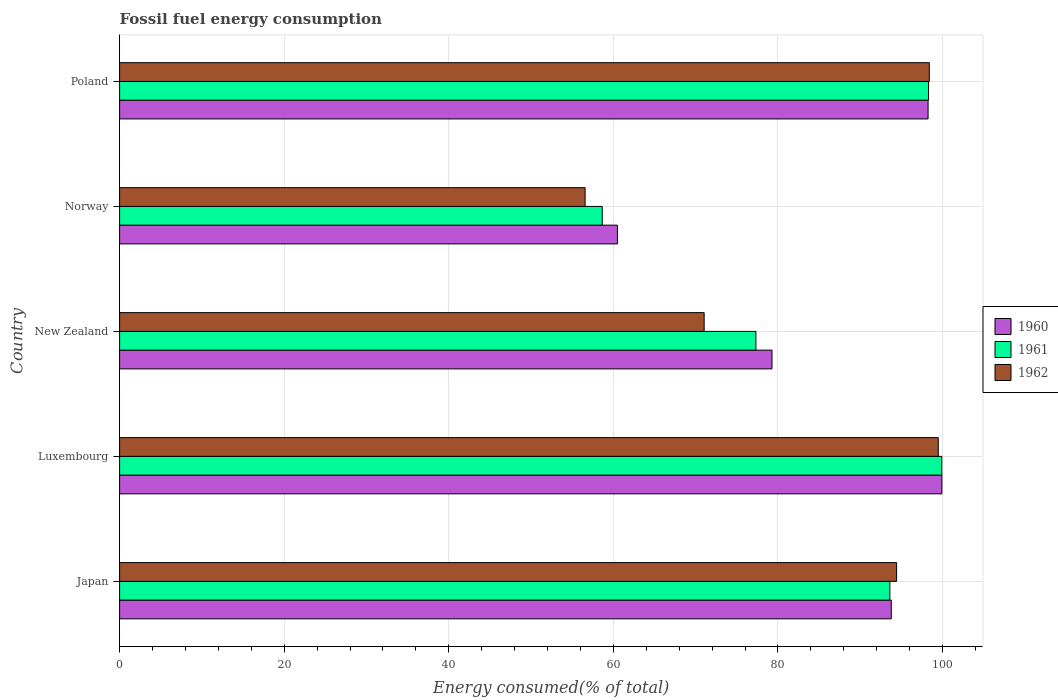Are the number of bars per tick equal to the number of legend labels?
Your answer should be compact. Yes. Are the number of bars on each tick of the Y-axis equal?
Provide a succinct answer. Yes. How many bars are there on the 4th tick from the top?
Your answer should be very brief. 3. How many bars are there on the 4th tick from the bottom?
Keep it short and to the point. 3. What is the label of the 4th group of bars from the top?
Your answer should be very brief. Luxembourg. What is the percentage of energy consumed in 1962 in Poland?
Your answer should be compact. 98.4. Across all countries, what is the maximum percentage of energy consumed in 1961?
Make the answer very short. 99.91. Across all countries, what is the minimum percentage of energy consumed in 1962?
Offer a very short reply. 56.57. In which country was the percentage of energy consumed in 1960 maximum?
Ensure brevity in your answer.  Luxembourg. What is the total percentage of energy consumed in 1962 in the graph?
Your answer should be very brief. 419.91. What is the difference between the percentage of energy consumed in 1961 in Japan and that in New Zealand?
Your response must be concise. 16.28. What is the difference between the percentage of energy consumed in 1960 in New Zealand and the percentage of energy consumed in 1962 in Norway?
Your answer should be very brief. 22.71. What is the average percentage of energy consumed in 1960 per country?
Give a very brief answer. 86.34. What is the difference between the percentage of energy consumed in 1960 and percentage of energy consumed in 1962 in New Zealand?
Your response must be concise. 8.24. What is the ratio of the percentage of energy consumed in 1960 in Luxembourg to that in Poland?
Keep it short and to the point. 1.02. Is the percentage of energy consumed in 1962 in Japan less than that in Norway?
Your answer should be very brief. No. Is the difference between the percentage of energy consumed in 1960 in Luxembourg and Poland greater than the difference between the percentage of energy consumed in 1962 in Luxembourg and Poland?
Offer a very short reply. Yes. What is the difference between the highest and the second highest percentage of energy consumed in 1960?
Offer a very short reply. 1.68. What is the difference between the highest and the lowest percentage of energy consumed in 1960?
Provide a succinct answer. 39.43. In how many countries, is the percentage of energy consumed in 1962 greater than the average percentage of energy consumed in 1962 taken over all countries?
Ensure brevity in your answer.  3. What does the 3rd bar from the top in Luxembourg represents?
Offer a terse response. 1960. Are all the bars in the graph horizontal?
Your answer should be compact. Yes. How many countries are there in the graph?
Offer a terse response. 5. What is the difference between two consecutive major ticks on the X-axis?
Keep it short and to the point. 20. Does the graph contain grids?
Offer a very short reply. Yes. How are the legend labels stacked?
Keep it short and to the point. Vertical. What is the title of the graph?
Your response must be concise. Fossil fuel energy consumption. What is the label or title of the X-axis?
Your answer should be very brief. Energy consumed(% of total). What is the Energy consumed(% of total) of 1960 in Japan?
Provide a short and direct response. 93.78. What is the Energy consumed(% of total) in 1961 in Japan?
Ensure brevity in your answer.  93.6. What is the Energy consumed(% of total) in 1962 in Japan?
Your answer should be compact. 94.42. What is the Energy consumed(% of total) in 1960 in Luxembourg?
Give a very brief answer. 99.92. What is the Energy consumed(% of total) in 1961 in Luxembourg?
Ensure brevity in your answer.  99.91. What is the Energy consumed(% of total) of 1962 in Luxembourg?
Offer a very short reply. 99.49. What is the Energy consumed(% of total) of 1960 in New Zealand?
Keep it short and to the point. 79.28. What is the Energy consumed(% of total) in 1961 in New Zealand?
Your response must be concise. 77.33. What is the Energy consumed(% of total) in 1962 in New Zealand?
Offer a terse response. 71.04. What is the Energy consumed(% of total) of 1960 in Norway?
Keep it short and to the point. 60.5. What is the Energy consumed(% of total) in 1961 in Norway?
Give a very brief answer. 58.65. What is the Energy consumed(% of total) of 1962 in Norway?
Provide a short and direct response. 56.57. What is the Energy consumed(% of total) in 1960 in Poland?
Keep it short and to the point. 98.25. What is the Energy consumed(% of total) of 1961 in Poland?
Ensure brevity in your answer.  98.3. What is the Energy consumed(% of total) in 1962 in Poland?
Ensure brevity in your answer.  98.4. Across all countries, what is the maximum Energy consumed(% of total) of 1960?
Provide a short and direct response. 99.92. Across all countries, what is the maximum Energy consumed(% of total) in 1961?
Offer a very short reply. 99.91. Across all countries, what is the maximum Energy consumed(% of total) in 1962?
Provide a short and direct response. 99.49. Across all countries, what is the minimum Energy consumed(% of total) of 1960?
Your answer should be compact. 60.5. Across all countries, what is the minimum Energy consumed(% of total) in 1961?
Provide a succinct answer. 58.65. Across all countries, what is the minimum Energy consumed(% of total) in 1962?
Your answer should be compact. 56.57. What is the total Energy consumed(% of total) in 1960 in the graph?
Provide a succinct answer. 431.72. What is the total Energy consumed(% of total) of 1961 in the graph?
Your answer should be very brief. 427.8. What is the total Energy consumed(% of total) in 1962 in the graph?
Ensure brevity in your answer.  419.91. What is the difference between the Energy consumed(% of total) in 1960 in Japan and that in Luxembourg?
Your answer should be very brief. -6.15. What is the difference between the Energy consumed(% of total) in 1961 in Japan and that in Luxembourg?
Offer a terse response. -6.31. What is the difference between the Energy consumed(% of total) in 1962 in Japan and that in Luxembourg?
Give a very brief answer. -5.07. What is the difference between the Energy consumed(% of total) of 1960 in Japan and that in New Zealand?
Your answer should be compact. 14.5. What is the difference between the Energy consumed(% of total) of 1961 in Japan and that in New Zealand?
Your answer should be compact. 16.28. What is the difference between the Energy consumed(% of total) in 1962 in Japan and that in New Zealand?
Make the answer very short. 23.38. What is the difference between the Energy consumed(% of total) of 1960 in Japan and that in Norway?
Ensure brevity in your answer.  33.28. What is the difference between the Energy consumed(% of total) in 1961 in Japan and that in Norway?
Give a very brief answer. 34.95. What is the difference between the Energy consumed(% of total) in 1962 in Japan and that in Norway?
Make the answer very short. 37.85. What is the difference between the Energy consumed(% of total) of 1960 in Japan and that in Poland?
Keep it short and to the point. -4.47. What is the difference between the Energy consumed(% of total) in 1961 in Japan and that in Poland?
Keep it short and to the point. -4.7. What is the difference between the Energy consumed(% of total) in 1962 in Japan and that in Poland?
Make the answer very short. -3.98. What is the difference between the Energy consumed(% of total) in 1960 in Luxembourg and that in New Zealand?
Provide a succinct answer. 20.65. What is the difference between the Energy consumed(% of total) in 1961 in Luxembourg and that in New Zealand?
Ensure brevity in your answer.  22.58. What is the difference between the Energy consumed(% of total) in 1962 in Luxembourg and that in New Zealand?
Your answer should be compact. 28.45. What is the difference between the Energy consumed(% of total) of 1960 in Luxembourg and that in Norway?
Your response must be concise. 39.43. What is the difference between the Energy consumed(% of total) in 1961 in Luxembourg and that in Norway?
Offer a terse response. 41.26. What is the difference between the Energy consumed(% of total) of 1962 in Luxembourg and that in Norway?
Make the answer very short. 42.92. What is the difference between the Energy consumed(% of total) in 1960 in Luxembourg and that in Poland?
Offer a very short reply. 1.68. What is the difference between the Energy consumed(% of total) in 1961 in Luxembourg and that in Poland?
Provide a short and direct response. 1.61. What is the difference between the Energy consumed(% of total) of 1962 in Luxembourg and that in Poland?
Offer a very short reply. 1.09. What is the difference between the Energy consumed(% of total) of 1960 in New Zealand and that in Norway?
Offer a terse response. 18.78. What is the difference between the Energy consumed(% of total) in 1961 in New Zealand and that in Norway?
Offer a terse response. 18.68. What is the difference between the Energy consumed(% of total) in 1962 in New Zealand and that in Norway?
Your answer should be compact. 14.47. What is the difference between the Energy consumed(% of total) in 1960 in New Zealand and that in Poland?
Keep it short and to the point. -18.97. What is the difference between the Energy consumed(% of total) of 1961 in New Zealand and that in Poland?
Your answer should be very brief. -20.98. What is the difference between the Energy consumed(% of total) of 1962 in New Zealand and that in Poland?
Your response must be concise. -27.36. What is the difference between the Energy consumed(% of total) in 1960 in Norway and that in Poland?
Offer a very short reply. -37.75. What is the difference between the Energy consumed(% of total) in 1961 in Norway and that in Poland?
Keep it short and to the point. -39.65. What is the difference between the Energy consumed(% of total) in 1962 in Norway and that in Poland?
Ensure brevity in your answer.  -41.83. What is the difference between the Energy consumed(% of total) in 1960 in Japan and the Energy consumed(% of total) in 1961 in Luxembourg?
Provide a succinct answer. -6.14. What is the difference between the Energy consumed(% of total) in 1960 in Japan and the Energy consumed(% of total) in 1962 in Luxembourg?
Offer a very short reply. -5.71. What is the difference between the Energy consumed(% of total) in 1961 in Japan and the Energy consumed(% of total) in 1962 in Luxembourg?
Your answer should be compact. -5.88. What is the difference between the Energy consumed(% of total) of 1960 in Japan and the Energy consumed(% of total) of 1961 in New Zealand?
Give a very brief answer. 16.45. What is the difference between the Energy consumed(% of total) of 1960 in Japan and the Energy consumed(% of total) of 1962 in New Zealand?
Keep it short and to the point. 22.74. What is the difference between the Energy consumed(% of total) in 1961 in Japan and the Energy consumed(% of total) in 1962 in New Zealand?
Your answer should be compact. 22.57. What is the difference between the Energy consumed(% of total) of 1960 in Japan and the Energy consumed(% of total) of 1961 in Norway?
Keep it short and to the point. 35.12. What is the difference between the Energy consumed(% of total) of 1960 in Japan and the Energy consumed(% of total) of 1962 in Norway?
Keep it short and to the point. 37.21. What is the difference between the Energy consumed(% of total) in 1961 in Japan and the Energy consumed(% of total) in 1962 in Norway?
Your answer should be compact. 37.03. What is the difference between the Energy consumed(% of total) of 1960 in Japan and the Energy consumed(% of total) of 1961 in Poland?
Your response must be concise. -4.53. What is the difference between the Energy consumed(% of total) in 1960 in Japan and the Energy consumed(% of total) in 1962 in Poland?
Keep it short and to the point. -4.62. What is the difference between the Energy consumed(% of total) in 1961 in Japan and the Energy consumed(% of total) in 1962 in Poland?
Give a very brief answer. -4.79. What is the difference between the Energy consumed(% of total) in 1960 in Luxembourg and the Energy consumed(% of total) in 1961 in New Zealand?
Offer a terse response. 22.6. What is the difference between the Energy consumed(% of total) in 1960 in Luxembourg and the Energy consumed(% of total) in 1962 in New Zealand?
Provide a short and direct response. 28.89. What is the difference between the Energy consumed(% of total) in 1961 in Luxembourg and the Energy consumed(% of total) in 1962 in New Zealand?
Provide a succinct answer. 28.88. What is the difference between the Energy consumed(% of total) in 1960 in Luxembourg and the Energy consumed(% of total) in 1961 in Norway?
Make the answer very short. 41.27. What is the difference between the Energy consumed(% of total) in 1960 in Luxembourg and the Energy consumed(% of total) in 1962 in Norway?
Your response must be concise. 43.35. What is the difference between the Energy consumed(% of total) of 1961 in Luxembourg and the Energy consumed(% of total) of 1962 in Norway?
Your answer should be compact. 43.34. What is the difference between the Energy consumed(% of total) of 1960 in Luxembourg and the Energy consumed(% of total) of 1961 in Poland?
Make the answer very short. 1.62. What is the difference between the Energy consumed(% of total) of 1960 in Luxembourg and the Energy consumed(% of total) of 1962 in Poland?
Provide a short and direct response. 1.53. What is the difference between the Energy consumed(% of total) of 1961 in Luxembourg and the Energy consumed(% of total) of 1962 in Poland?
Offer a terse response. 1.52. What is the difference between the Energy consumed(% of total) of 1960 in New Zealand and the Energy consumed(% of total) of 1961 in Norway?
Ensure brevity in your answer.  20.63. What is the difference between the Energy consumed(% of total) in 1960 in New Zealand and the Energy consumed(% of total) in 1962 in Norway?
Your answer should be very brief. 22.71. What is the difference between the Energy consumed(% of total) of 1961 in New Zealand and the Energy consumed(% of total) of 1962 in Norway?
Make the answer very short. 20.76. What is the difference between the Energy consumed(% of total) of 1960 in New Zealand and the Energy consumed(% of total) of 1961 in Poland?
Give a very brief answer. -19.02. What is the difference between the Energy consumed(% of total) in 1960 in New Zealand and the Energy consumed(% of total) in 1962 in Poland?
Your answer should be very brief. -19.12. What is the difference between the Energy consumed(% of total) of 1961 in New Zealand and the Energy consumed(% of total) of 1962 in Poland?
Provide a succinct answer. -21.07. What is the difference between the Energy consumed(% of total) in 1960 in Norway and the Energy consumed(% of total) in 1961 in Poland?
Your answer should be very brief. -37.81. What is the difference between the Energy consumed(% of total) in 1960 in Norway and the Energy consumed(% of total) in 1962 in Poland?
Offer a very short reply. -37.9. What is the difference between the Energy consumed(% of total) in 1961 in Norway and the Energy consumed(% of total) in 1962 in Poland?
Your response must be concise. -39.74. What is the average Energy consumed(% of total) of 1960 per country?
Provide a short and direct response. 86.34. What is the average Energy consumed(% of total) in 1961 per country?
Offer a terse response. 85.56. What is the average Energy consumed(% of total) in 1962 per country?
Your answer should be very brief. 83.98. What is the difference between the Energy consumed(% of total) in 1960 and Energy consumed(% of total) in 1961 in Japan?
Your answer should be very brief. 0.17. What is the difference between the Energy consumed(% of total) in 1960 and Energy consumed(% of total) in 1962 in Japan?
Ensure brevity in your answer.  -0.64. What is the difference between the Energy consumed(% of total) of 1961 and Energy consumed(% of total) of 1962 in Japan?
Ensure brevity in your answer.  -0.82. What is the difference between the Energy consumed(% of total) of 1960 and Energy consumed(% of total) of 1961 in Luxembourg?
Provide a succinct answer. 0.01. What is the difference between the Energy consumed(% of total) in 1960 and Energy consumed(% of total) in 1962 in Luxembourg?
Ensure brevity in your answer.  0.44. What is the difference between the Energy consumed(% of total) in 1961 and Energy consumed(% of total) in 1962 in Luxembourg?
Ensure brevity in your answer.  0.42. What is the difference between the Energy consumed(% of total) in 1960 and Energy consumed(% of total) in 1961 in New Zealand?
Provide a succinct answer. 1.95. What is the difference between the Energy consumed(% of total) in 1960 and Energy consumed(% of total) in 1962 in New Zealand?
Make the answer very short. 8.24. What is the difference between the Energy consumed(% of total) in 1961 and Energy consumed(% of total) in 1962 in New Zealand?
Provide a succinct answer. 6.29. What is the difference between the Energy consumed(% of total) of 1960 and Energy consumed(% of total) of 1961 in Norway?
Offer a very short reply. 1.85. What is the difference between the Energy consumed(% of total) of 1960 and Energy consumed(% of total) of 1962 in Norway?
Provide a short and direct response. 3.93. What is the difference between the Energy consumed(% of total) of 1961 and Energy consumed(% of total) of 1962 in Norway?
Provide a short and direct response. 2.08. What is the difference between the Energy consumed(% of total) of 1960 and Energy consumed(% of total) of 1961 in Poland?
Provide a succinct answer. -0.06. What is the difference between the Energy consumed(% of total) in 1960 and Energy consumed(% of total) in 1962 in Poland?
Offer a very short reply. -0.15. What is the difference between the Energy consumed(% of total) of 1961 and Energy consumed(% of total) of 1962 in Poland?
Provide a short and direct response. -0.09. What is the ratio of the Energy consumed(% of total) of 1960 in Japan to that in Luxembourg?
Offer a very short reply. 0.94. What is the ratio of the Energy consumed(% of total) in 1961 in Japan to that in Luxembourg?
Provide a short and direct response. 0.94. What is the ratio of the Energy consumed(% of total) of 1962 in Japan to that in Luxembourg?
Your answer should be very brief. 0.95. What is the ratio of the Energy consumed(% of total) of 1960 in Japan to that in New Zealand?
Your response must be concise. 1.18. What is the ratio of the Energy consumed(% of total) of 1961 in Japan to that in New Zealand?
Provide a succinct answer. 1.21. What is the ratio of the Energy consumed(% of total) of 1962 in Japan to that in New Zealand?
Your answer should be very brief. 1.33. What is the ratio of the Energy consumed(% of total) in 1960 in Japan to that in Norway?
Offer a terse response. 1.55. What is the ratio of the Energy consumed(% of total) in 1961 in Japan to that in Norway?
Keep it short and to the point. 1.6. What is the ratio of the Energy consumed(% of total) in 1962 in Japan to that in Norway?
Your answer should be compact. 1.67. What is the ratio of the Energy consumed(% of total) in 1960 in Japan to that in Poland?
Keep it short and to the point. 0.95. What is the ratio of the Energy consumed(% of total) of 1961 in Japan to that in Poland?
Provide a short and direct response. 0.95. What is the ratio of the Energy consumed(% of total) of 1962 in Japan to that in Poland?
Offer a terse response. 0.96. What is the ratio of the Energy consumed(% of total) of 1960 in Luxembourg to that in New Zealand?
Offer a very short reply. 1.26. What is the ratio of the Energy consumed(% of total) of 1961 in Luxembourg to that in New Zealand?
Your answer should be compact. 1.29. What is the ratio of the Energy consumed(% of total) in 1962 in Luxembourg to that in New Zealand?
Your response must be concise. 1.4. What is the ratio of the Energy consumed(% of total) of 1960 in Luxembourg to that in Norway?
Ensure brevity in your answer.  1.65. What is the ratio of the Energy consumed(% of total) of 1961 in Luxembourg to that in Norway?
Offer a very short reply. 1.7. What is the ratio of the Energy consumed(% of total) of 1962 in Luxembourg to that in Norway?
Offer a terse response. 1.76. What is the ratio of the Energy consumed(% of total) of 1960 in Luxembourg to that in Poland?
Your answer should be very brief. 1.02. What is the ratio of the Energy consumed(% of total) in 1961 in Luxembourg to that in Poland?
Offer a very short reply. 1.02. What is the ratio of the Energy consumed(% of total) in 1962 in Luxembourg to that in Poland?
Offer a terse response. 1.01. What is the ratio of the Energy consumed(% of total) in 1960 in New Zealand to that in Norway?
Provide a succinct answer. 1.31. What is the ratio of the Energy consumed(% of total) of 1961 in New Zealand to that in Norway?
Your answer should be very brief. 1.32. What is the ratio of the Energy consumed(% of total) in 1962 in New Zealand to that in Norway?
Give a very brief answer. 1.26. What is the ratio of the Energy consumed(% of total) of 1960 in New Zealand to that in Poland?
Make the answer very short. 0.81. What is the ratio of the Energy consumed(% of total) of 1961 in New Zealand to that in Poland?
Keep it short and to the point. 0.79. What is the ratio of the Energy consumed(% of total) of 1962 in New Zealand to that in Poland?
Make the answer very short. 0.72. What is the ratio of the Energy consumed(% of total) of 1960 in Norway to that in Poland?
Your answer should be very brief. 0.62. What is the ratio of the Energy consumed(% of total) of 1961 in Norway to that in Poland?
Your response must be concise. 0.6. What is the ratio of the Energy consumed(% of total) in 1962 in Norway to that in Poland?
Your answer should be compact. 0.57. What is the difference between the highest and the second highest Energy consumed(% of total) of 1960?
Your answer should be very brief. 1.68. What is the difference between the highest and the second highest Energy consumed(% of total) of 1961?
Offer a terse response. 1.61. What is the difference between the highest and the second highest Energy consumed(% of total) of 1962?
Make the answer very short. 1.09. What is the difference between the highest and the lowest Energy consumed(% of total) of 1960?
Make the answer very short. 39.43. What is the difference between the highest and the lowest Energy consumed(% of total) in 1961?
Keep it short and to the point. 41.26. What is the difference between the highest and the lowest Energy consumed(% of total) in 1962?
Keep it short and to the point. 42.92. 